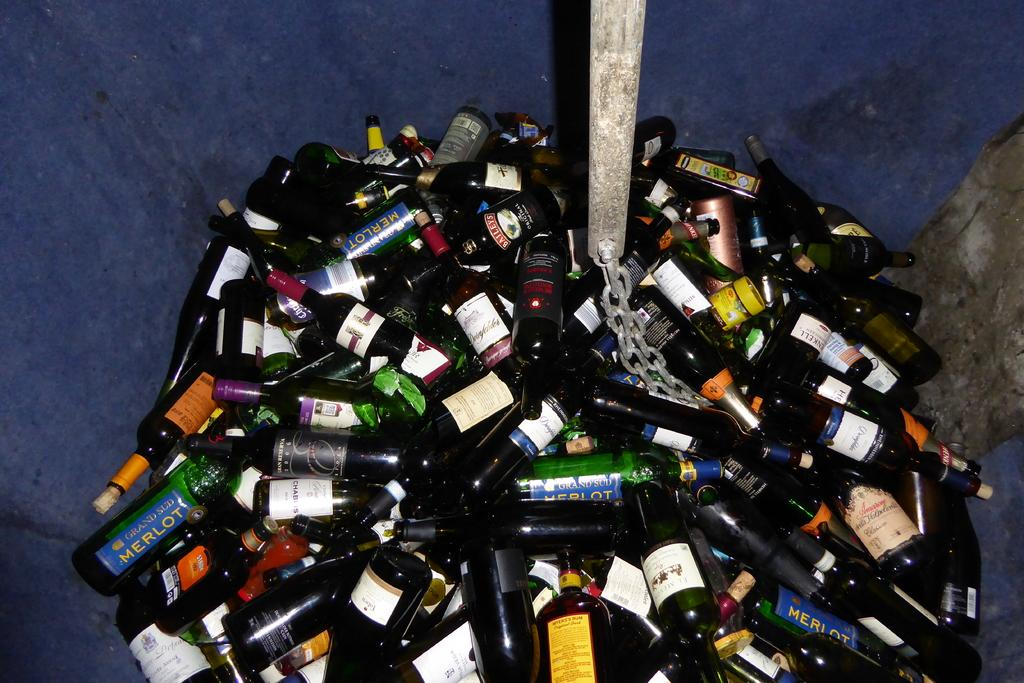<image>
Write a terse but informative summary of the picture. A green bottle of Merlot is in a pile of bottles. 